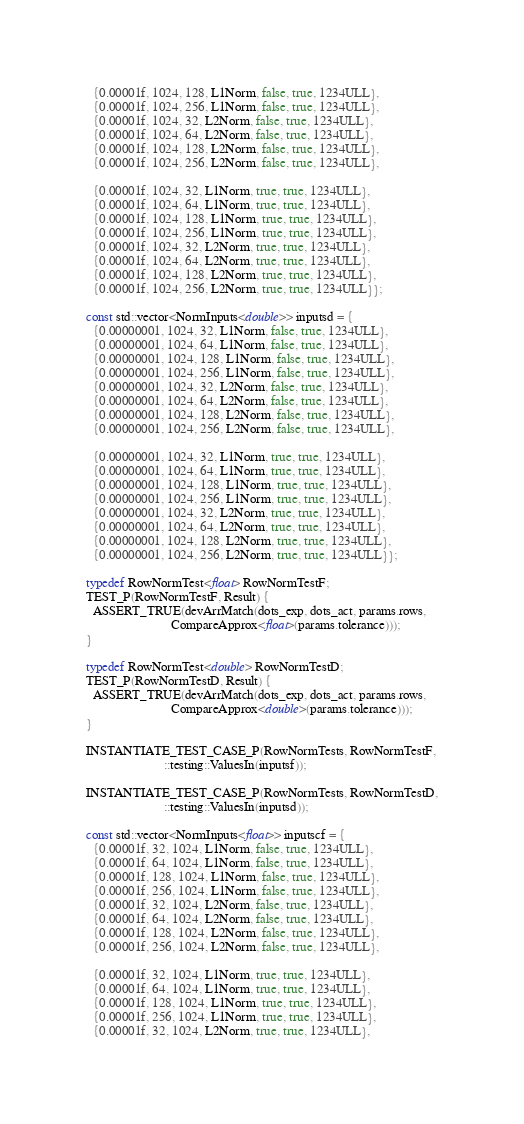<code> <loc_0><loc_0><loc_500><loc_500><_Cuda_>  {0.00001f, 1024, 128, L1Norm, false, true, 1234ULL},
  {0.00001f, 1024, 256, L1Norm, false, true, 1234ULL},
  {0.00001f, 1024, 32, L2Norm, false, true, 1234ULL},
  {0.00001f, 1024, 64, L2Norm, false, true, 1234ULL},
  {0.00001f, 1024, 128, L2Norm, false, true, 1234ULL},
  {0.00001f, 1024, 256, L2Norm, false, true, 1234ULL},

  {0.00001f, 1024, 32, L1Norm, true, true, 1234ULL},
  {0.00001f, 1024, 64, L1Norm, true, true, 1234ULL},
  {0.00001f, 1024, 128, L1Norm, true, true, 1234ULL},
  {0.00001f, 1024, 256, L1Norm, true, true, 1234ULL},
  {0.00001f, 1024, 32, L2Norm, true, true, 1234ULL},
  {0.00001f, 1024, 64, L2Norm, true, true, 1234ULL},
  {0.00001f, 1024, 128, L2Norm, true, true, 1234ULL},
  {0.00001f, 1024, 256, L2Norm, true, true, 1234ULL}};

const std::vector<NormInputs<double>> inputsd = {
  {0.00000001, 1024, 32, L1Norm, false, true, 1234ULL},
  {0.00000001, 1024, 64, L1Norm, false, true, 1234ULL},
  {0.00000001, 1024, 128, L1Norm, false, true, 1234ULL},
  {0.00000001, 1024, 256, L1Norm, false, true, 1234ULL},
  {0.00000001, 1024, 32, L2Norm, false, true, 1234ULL},
  {0.00000001, 1024, 64, L2Norm, false, true, 1234ULL},
  {0.00000001, 1024, 128, L2Norm, false, true, 1234ULL},
  {0.00000001, 1024, 256, L2Norm, false, true, 1234ULL},

  {0.00000001, 1024, 32, L1Norm, true, true, 1234ULL},
  {0.00000001, 1024, 64, L1Norm, true, true, 1234ULL},
  {0.00000001, 1024, 128, L1Norm, true, true, 1234ULL},
  {0.00000001, 1024, 256, L1Norm, true, true, 1234ULL},
  {0.00000001, 1024, 32, L2Norm, true, true, 1234ULL},
  {0.00000001, 1024, 64, L2Norm, true, true, 1234ULL},
  {0.00000001, 1024, 128, L2Norm, true, true, 1234ULL},
  {0.00000001, 1024, 256, L2Norm, true, true, 1234ULL}};

typedef RowNormTest<float> RowNormTestF;
TEST_P(RowNormTestF, Result) {
  ASSERT_TRUE(devArrMatch(dots_exp, dots_act, params.rows,
                          CompareApprox<float>(params.tolerance)));
}

typedef RowNormTest<double> RowNormTestD;
TEST_P(RowNormTestD, Result) {
  ASSERT_TRUE(devArrMatch(dots_exp, dots_act, params.rows,
                          CompareApprox<double>(params.tolerance)));
}

INSTANTIATE_TEST_CASE_P(RowNormTests, RowNormTestF,
                        ::testing::ValuesIn(inputsf));

INSTANTIATE_TEST_CASE_P(RowNormTests, RowNormTestD,
                        ::testing::ValuesIn(inputsd));

const std::vector<NormInputs<float>> inputscf = {
  {0.00001f, 32, 1024, L1Norm, false, true, 1234ULL},
  {0.00001f, 64, 1024, L1Norm, false, true, 1234ULL},
  {0.00001f, 128, 1024, L1Norm, false, true, 1234ULL},
  {0.00001f, 256, 1024, L1Norm, false, true, 1234ULL},
  {0.00001f, 32, 1024, L2Norm, false, true, 1234ULL},
  {0.00001f, 64, 1024, L2Norm, false, true, 1234ULL},
  {0.00001f, 128, 1024, L2Norm, false, true, 1234ULL},
  {0.00001f, 256, 1024, L2Norm, false, true, 1234ULL},

  {0.00001f, 32, 1024, L1Norm, true, true, 1234ULL},
  {0.00001f, 64, 1024, L1Norm, true, true, 1234ULL},
  {0.00001f, 128, 1024, L1Norm, true, true, 1234ULL},
  {0.00001f, 256, 1024, L1Norm, true, true, 1234ULL},
  {0.00001f, 32, 1024, L2Norm, true, true, 1234ULL},</code> 